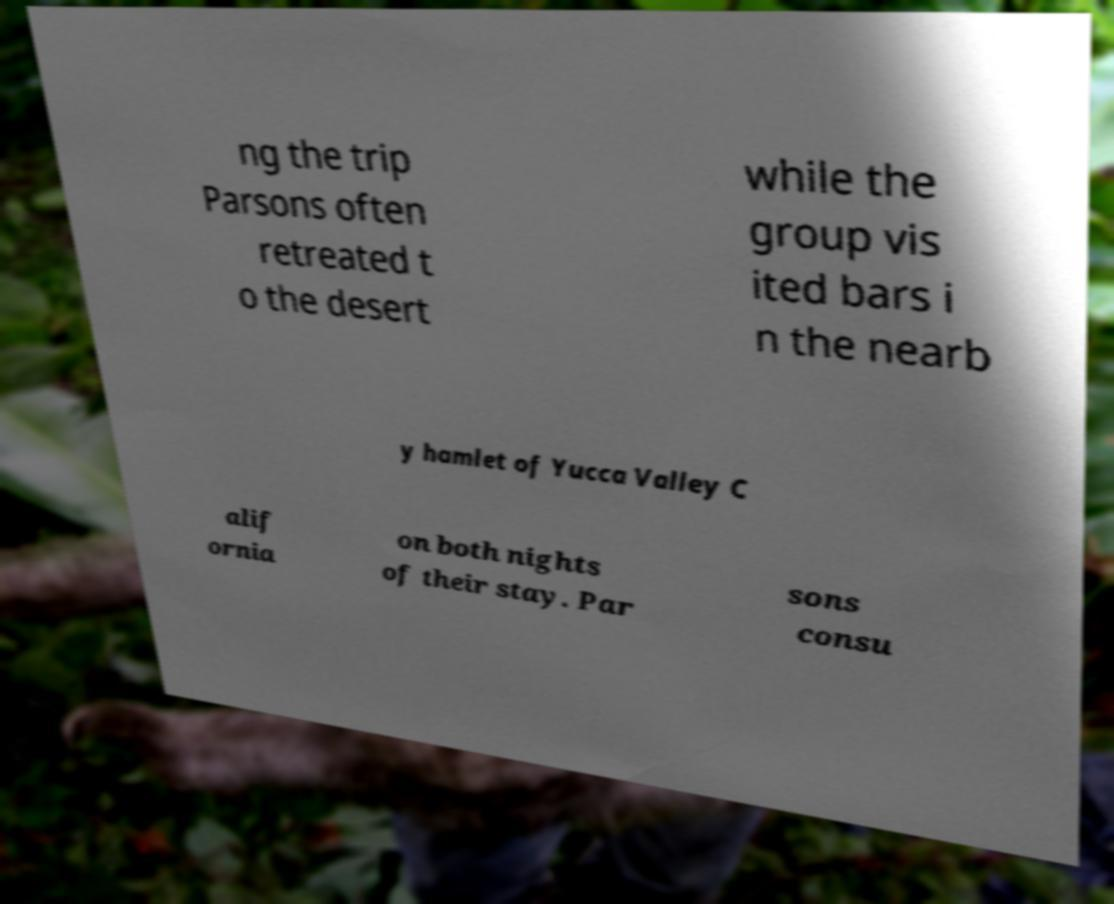Please identify and transcribe the text found in this image. ng the trip Parsons often retreated t o the desert while the group vis ited bars i n the nearb y hamlet of Yucca Valley C alif ornia on both nights of their stay. Par sons consu 